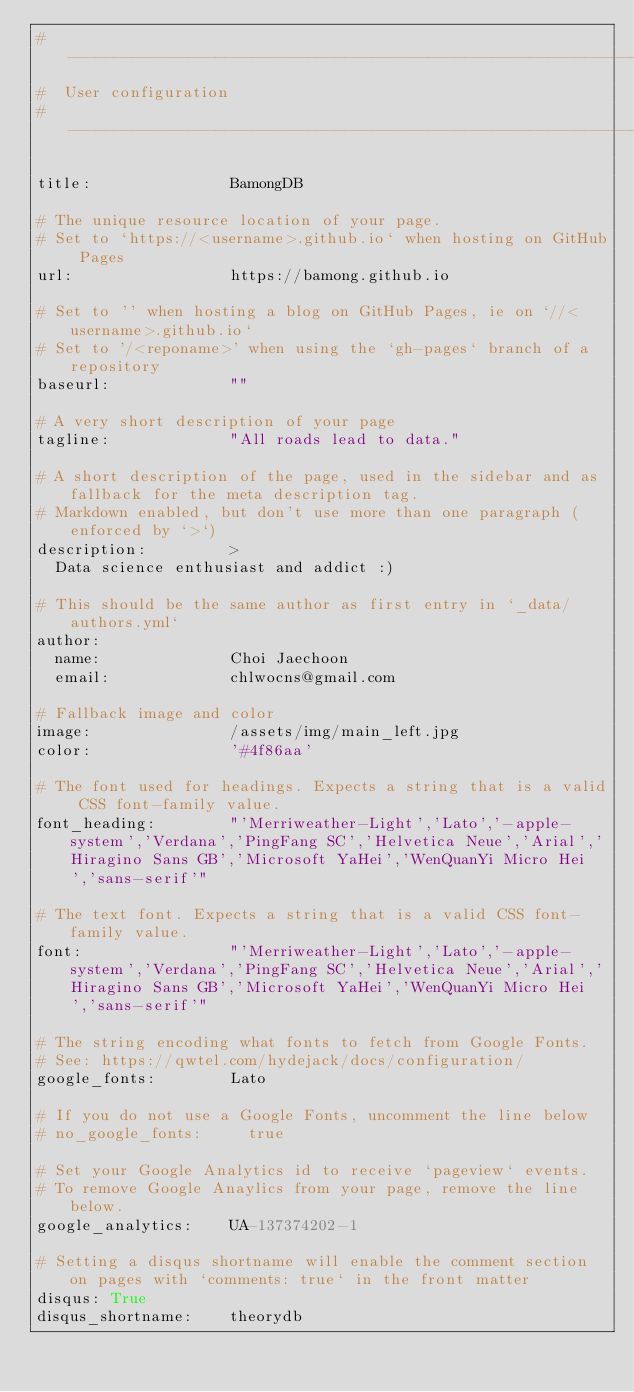<code> <loc_0><loc_0><loc_500><loc_500><_YAML_># -----------------------------------------------------------------------------
#  User configuration
# -----------------------------------------------------------------------------

title:               BamongDB

# The unique resource location of your page.
# Set to `https://<username>.github.io` when hosting on GitHub Pages
url:                 https://bamong.github.io

# Set to '' when hosting a blog on GitHub Pages, ie on `//<username>.github.io`
# Set to '/<reponame>' when using the `gh-pages` branch of a repository
baseurl:             ""

# A very short description of your page
tagline:             "All roads lead to data."

# A short description of the page, used in the sidebar and as fallback for the meta description tag.
# Markdown enabled, but don't use more than one paragraph (enforced by `>`)
description:         >
  Data science enthusiast and addict :)

# This should be the same author as first entry in `_data/authors.yml`
author:
  name:              Choi Jaechoon
  email:             chlwocns@gmail.com

# Fallback image and color
image:               /assets/img/main_left.jpg
color:               '#4f86aa'

# The font used for headings. Expects a string that is a valid CSS font-family value.
font_heading:        "'Merriweather-Light','Lato','-apple-system','Verdana','PingFang SC','Helvetica Neue','Arial','Hiragino Sans GB','Microsoft YaHei','WenQuanYi Micro Hei','sans-serif'"

# The text font. Expects a string that is a valid CSS font-family value.
font:                "'Merriweather-Light','Lato','-apple-system','Verdana','PingFang SC','Helvetica Neue','Arial','Hiragino Sans GB','Microsoft YaHei','WenQuanYi Micro Hei','sans-serif'"

# The string encoding what fonts to fetch from Google Fonts.
# See: https://qwtel.com/hydejack/docs/configuration/
google_fonts:        Lato

# If you do not use a Google Fonts, uncomment the line below
# no_google_fonts:     true

# Set your Google Analytics id to receive `pageview` events.
# To remove Google Anaylics from your page, remove the line below.
google_analytics:    UA-137374202-1

# Setting a disqus shortname will enable the comment section on pages with `comments: true` in the front matter
disqus: True
disqus_shortname:    theorydb
</code> 